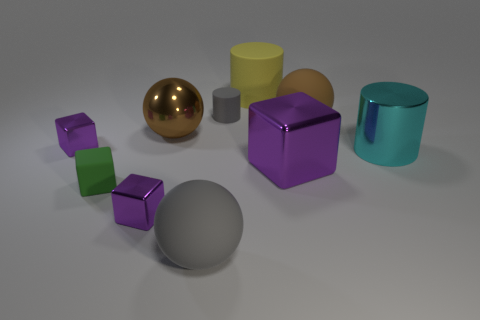Subtract all matte cylinders. How many cylinders are left? 1 Subtract all yellow cylinders. How many brown balls are left? 2 Subtract all green blocks. How many blocks are left? 3 Subtract 2 blocks. How many blocks are left? 2 Subtract all cyan balls. Subtract all yellow cubes. How many balls are left? 3 Subtract all cyan things. Subtract all metallic objects. How many objects are left? 4 Add 4 big matte spheres. How many big matte spheres are left? 6 Add 8 big metallic cylinders. How many big metallic cylinders exist? 9 Subtract 0 blue cylinders. How many objects are left? 10 Subtract all cubes. How many objects are left? 6 